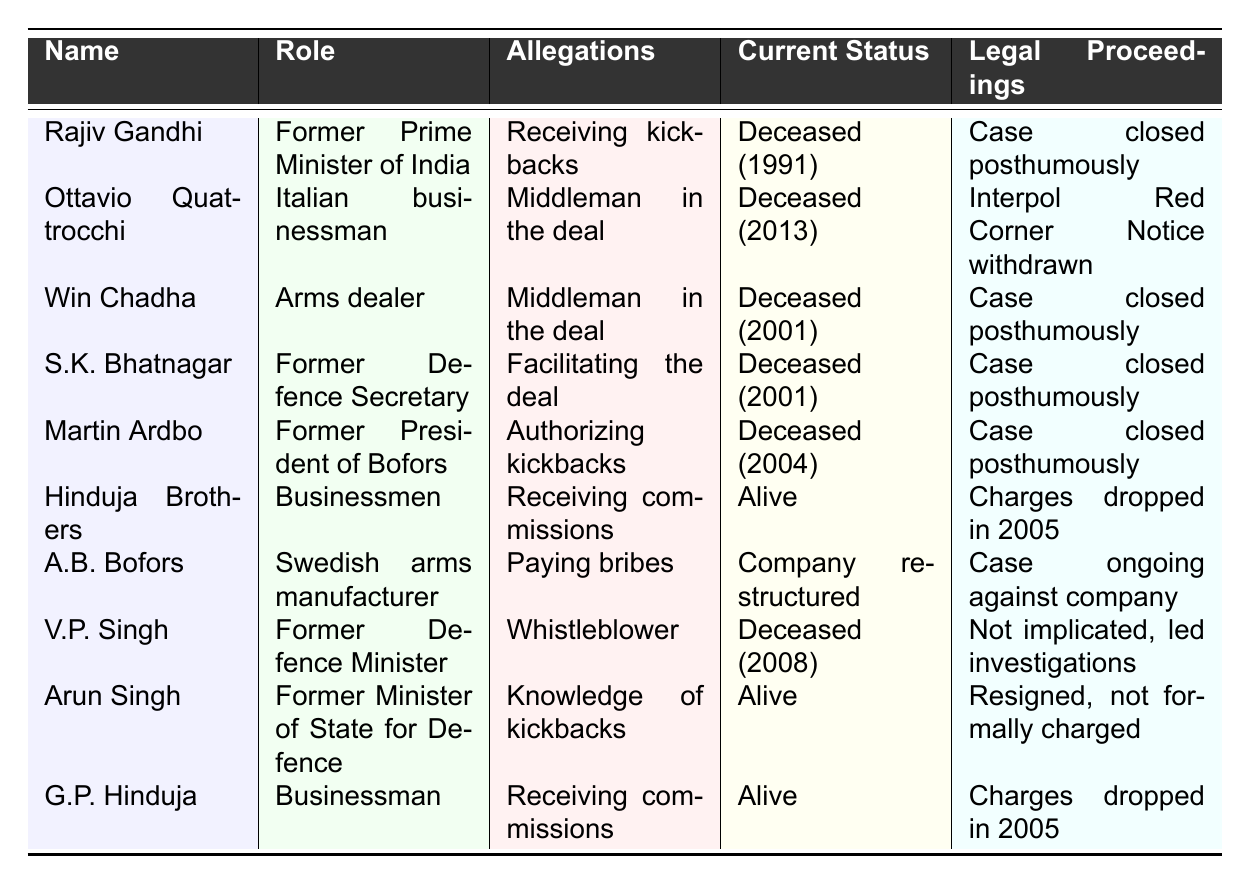What allegations are associated with Rajiv Gandhi? According to the table, Rajiv Gandhi is implicated in the allegations of receiving kickbacks.
Answer: Receiving kickbacks What is the current status of Ottavio Quattrocchi? The table states that Ottavio Quattrocchi is deceased and passed away in 2013.
Answer: Deceased (2013) How many individuals listed are currently alive? The table shows that there are 3 individuals currently alive: Hinduja Brothers, Arun Singh, and G.P. Hinduja.
Answer: 3 Which allegations are associated with the Hinduja Brothers? The table indicates that the Hinduja Brothers are alleged to have received commissions.
Answer: Receiving commissions What is the relationship between V.P. Singh and the legal proceedings? According to the table, V.P. Singh is a whistleblower and is not implicated in any legal proceedings but led investigations.
Answer: Not implicated, led investigations Which individual was the former President of Bofors? The table specifies that Martin Ardbo was the former President of Bofors.
Answer: Martin Ardbo What year did Win Chadha pass away? The table shows that Win Chadha died in 2001.
Answer: 2001 Are there any individuals against whom charges were dropped? Yes, the table indicates that charges against the Hinduja Brothers and G.P. Hinduja were dropped in 2005.
Answer: Yes Identify the total number of deceased individuals listed in the table. The table shows 6 deceased individuals: Rajiv Gandhi, Ottavio Quattrocchi, Win Chadha, S.K. Bhatnagar, Martin Ardbo, and V.P. Singh.
Answer: 6 Which individual has ongoing legal proceedings? A.B. Bofors is mentioned in the table to have ongoing legal proceedings against the company due to allegations of paying bribes.
Answer: A.B. Bofors Did Arun Singh face formal charges? The table states that Arun Singh resigned and was not formally charged.
Answer: No 